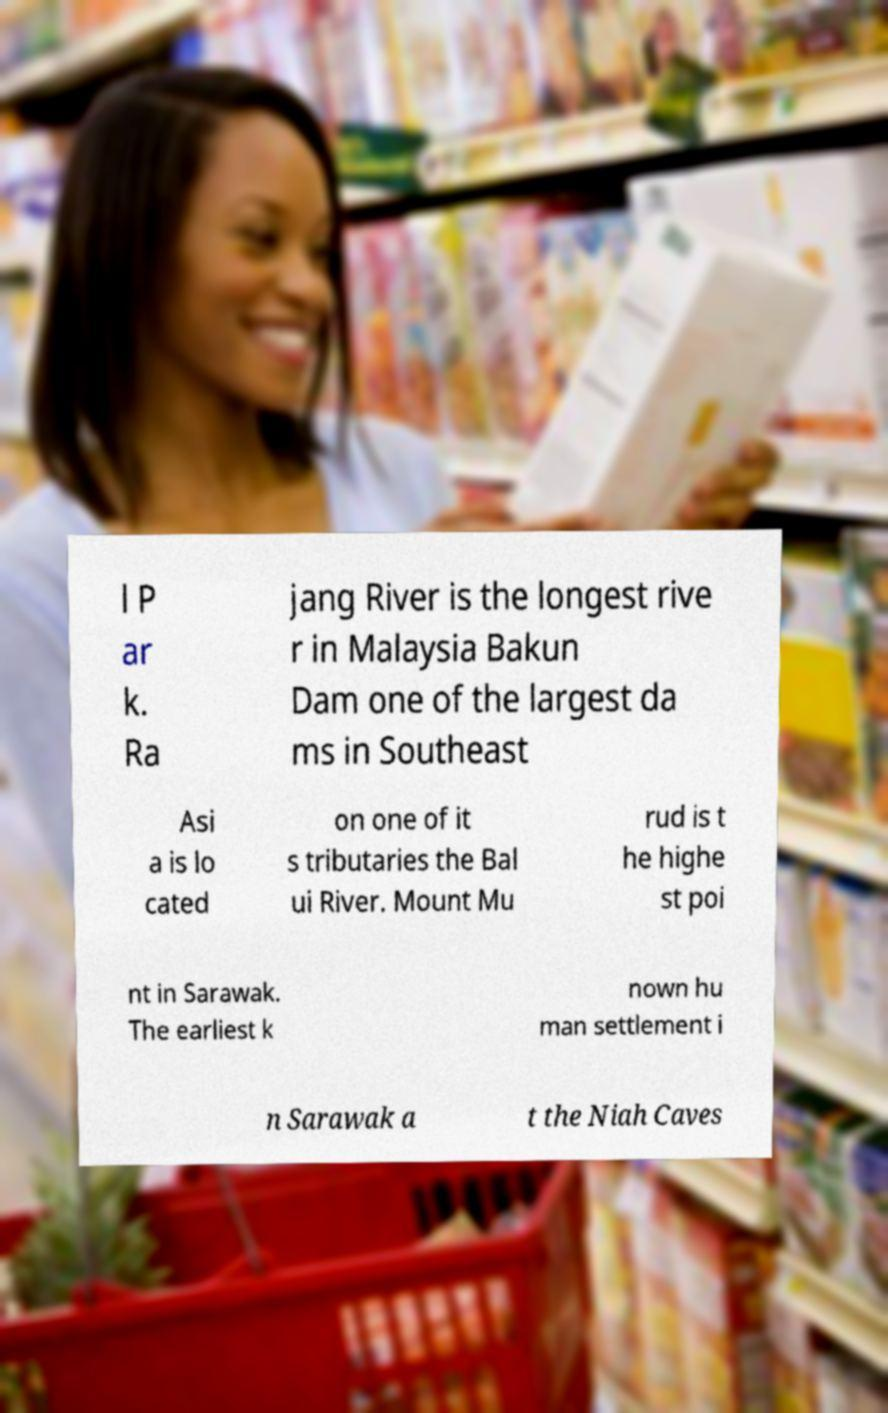Can you accurately transcribe the text from the provided image for me? l P ar k. Ra jang River is the longest rive r in Malaysia Bakun Dam one of the largest da ms in Southeast Asi a is lo cated on one of it s tributaries the Bal ui River. Mount Mu rud is t he highe st poi nt in Sarawak. The earliest k nown hu man settlement i n Sarawak a t the Niah Caves 